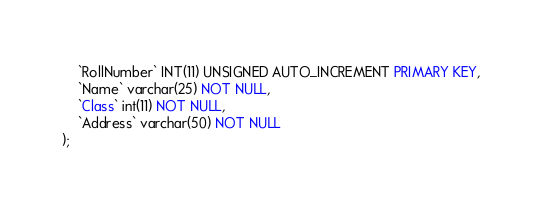<code> <loc_0><loc_0><loc_500><loc_500><_SQL_>	`RollNumber` INT(11) UNSIGNED AUTO_INCREMENT PRIMARY KEY, 
    `Name` varchar(25) NOT NULL,
    `Class` int(11) NOT NULL,
    `Address` varchar(50) NOT NULL
);</code> 